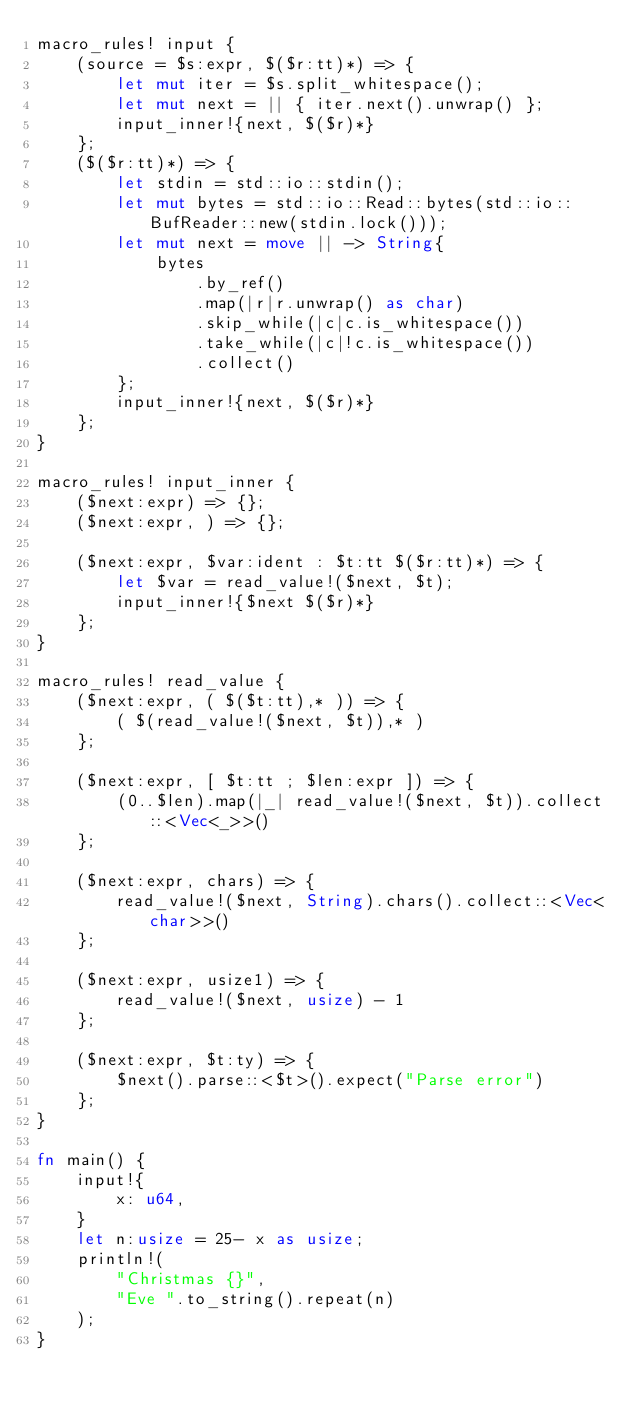Convert code to text. <code><loc_0><loc_0><loc_500><loc_500><_Rust_>macro_rules! input {
    (source = $s:expr, $($r:tt)*) => {
        let mut iter = $s.split_whitespace();
        let mut next = || { iter.next().unwrap() };
        input_inner!{next, $($r)*}
    };
    ($($r:tt)*) => {
        let stdin = std::io::stdin();
        let mut bytes = std::io::Read::bytes(std::io::BufReader::new(stdin.lock()));
        let mut next = move || -> String{
            bytes
                .by_ref()
                .map(|r|r.unwrap() as char)
                .skip_while(|c|c.is_whitespace())
                .take_while(|c|!c.is_whitespace())
                .collect()
        };
        input_inner!{next, $($r)*}
    };
}

macro_rules! input_inner {
    ($next:expr) => {};
    ($next:expr, ) => {};

    ($next:expr, $var:ident : $t:tt $($r:tt)*) => {
        let $var = read_value!($next, $t);
        input_inner!{$next $($r)*}
    };
}

macro_rules! read_value {
    ($next:expr, ( $($t:tt),* )) => {
        ( $(read_value!($next, $t)),* )
    };

    ($next:expr, [ $t:tt ; $len:expr ]) => {
        (0..$len).map(|_| read_value!($next, $t)).collect::<Vec<_>>()
    };

    ($next:expr, chars) => {
        read_value!($next, String).chars().collect::<Vec<char>>()
    };

    ($next:expr, usize1) => {
        read_value!($next, usize) - 1
    };

    ($next:expr, $t:ty) => {
        $next().parse::<$t>().expect("Parse error")
    };
}

fn main() {
    input!{
        x: u64,
    }
    let n:usize = 25- x as usize;
    println!(
        "Christmas {}", 
        "Eve ".to_string().repeat(n)
    );
}
</code> 